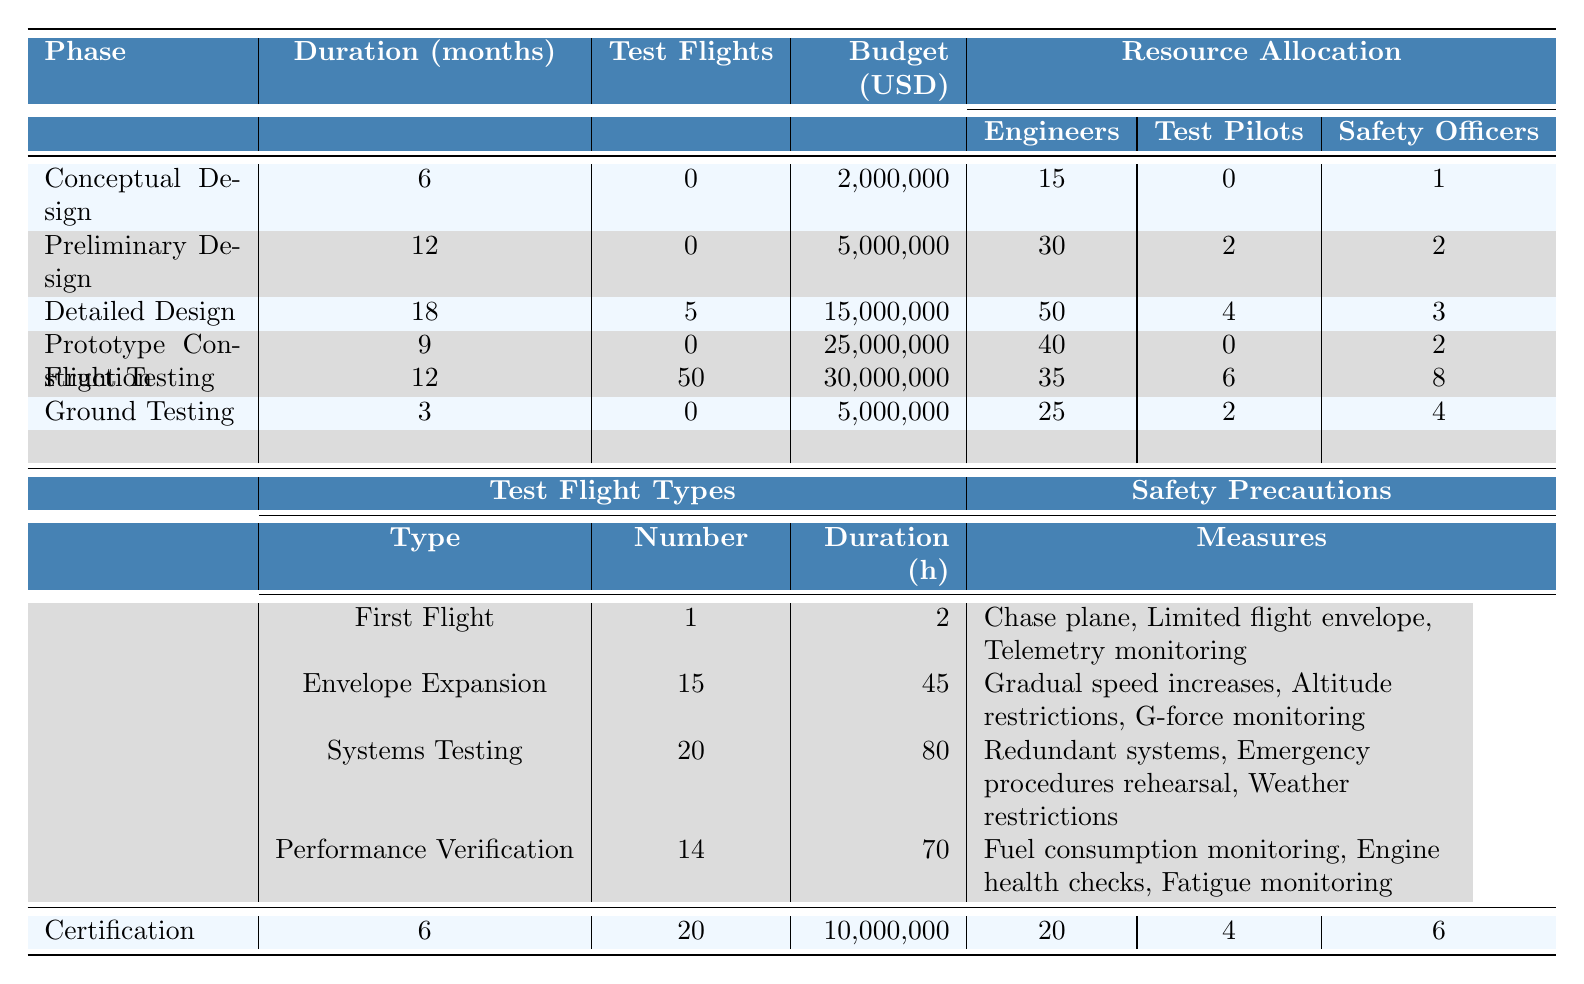What is the total budget allocated for the Detailed Design phase? The budget for the Detailed Design phase, as stated in the table, is $15,000,000.
Answer: 15,000,000 How many test flights are scheduled during the Flight Testing phase? According to the table, the Flight Testing phase has 50 test flights scheduled.
Answer: 50 During which phase is the highest number of engineers allocated? The Detailed Design phase allocates the highest number of engineers at 50.
Answer: Detailed Design How much total budget is allocated across all phases? The budgets for each phase are summed: $2,000,000 + $5,000,000 + $15,000,000 + $25,000,000 + $5,000,000 + $30,000,000 + $10,000,000 = $92,000,000.
Answer: 92,000,000 Are there any phases with zero test flights scheduled? Yes, the Conceptual Design, Preliminary Design, Prototype Construction, and Ground Testing phases have zero test flights scheduled.
Answer: Yes What is the average duration of all the phases? The total duration of all phases is 6 + 12 + 18 + 9 + 3 + 12 + 6 = 66 months. There are 7 phases, so the average duration is 66 / 7 ≈ 9.43 months.
Answer: 9.43 months In the Flight Testing phase, how many flights are designated for Systems Testing? The Systems Testing category within the Flight Testing phase accounts for 20 flights.
Answer: 20 Which phase has the most safety officers allocated, and how many? The Flight Testing phase has the most safety officers with a total of 8 allocated.
Answer: Flight Testing, 8 What is the difference in the number of engineers allocated between the Prototype Construction and Flight Testing phases? For Prototype Construction, there are 40 engineers, and for Flight Testing, there are 35 engineers. The difference is 40 - 35 = 5 engineers.
Answer: 5 Is the number of test pilots greater during the Certification phase than during the Conceptual Design phase? Yes, there are 4 test pilots during the Certification phase, while there are 0 in the Conceptual Design phase.
Answer: Yes What percentage of the total allocated budget is spent on the Prototype Construction phase? The budget for Prototype Construction is $25,000,000. The total budget is $92,000,000. The percentage is ($25,000,000 / $92,000,000) * 100 ≈ 27.17%.
Answer: 27.17% 